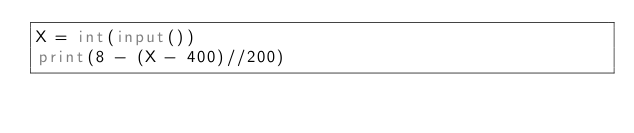Convert code to text. <code><loc_0><loc_0><loc_500><loc_500><_Python_>X = int(input())
print(8 - (X - 400)//200)</code> 